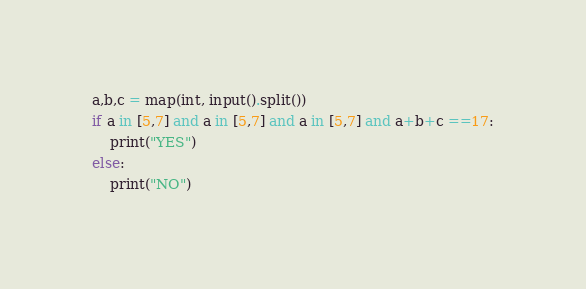Convert code to text. <code><loc_0><loc_0><loc_500><loc_500><_Python_>a,b,c = map(int, input().split())
if a in [5,7] and a in [5,7] and a in [5,7] and a+b+c ==17:
    print("YES")
else:
    print("NO")</code> 